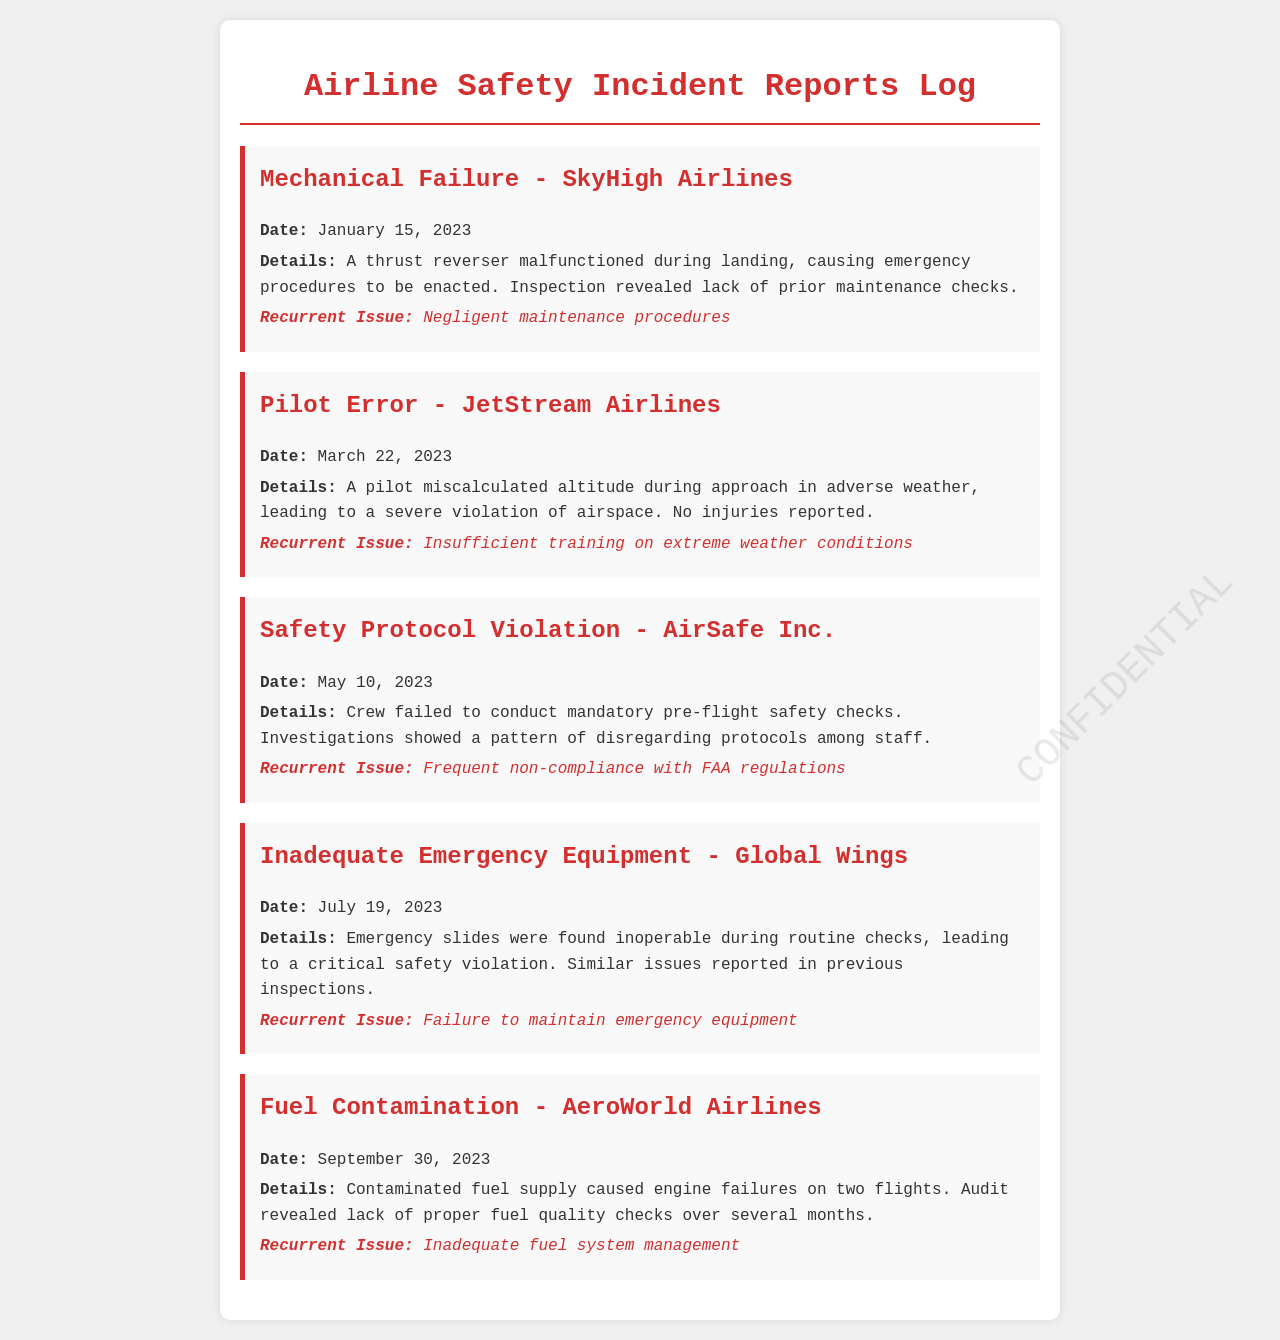what incident occurred on January 15, 2023? The incident involved a malfunction of a thrust reverser during landing, which led to emergency procedures.
Answer: Mechanical Failure - SkyHigh Airlines which airline was involved in the pilot error incident? The pilot error incident was linked to JetStream Airlines.
Answer: JetStream Airlines what recurrent issue was noted in the incident on May 10, 2023? The recurrent issue involved frequent non-compliance with FAA regulations.
Answer: Frequent non-compliance with FAA regulations how many incidents are reported in this document? The document contains five distinct safety incident reports.
Answer: 5 what was found inoperable during the routine checks on July 19, 2023? Emergency slides were found inoperable during the routine checks.
Answer: Emergency slides what was the primary cause of the fuel contamination incident? The primary cause was a contaminated fuel supply leading to engine failures.
Answer: Contaminated fuel supply what kind of training issue was highlighted in the pilot error incident? The incident highlighted insufficient training on extreme weather conditions.
Answer: Insufficient training on extreme weather conditions 